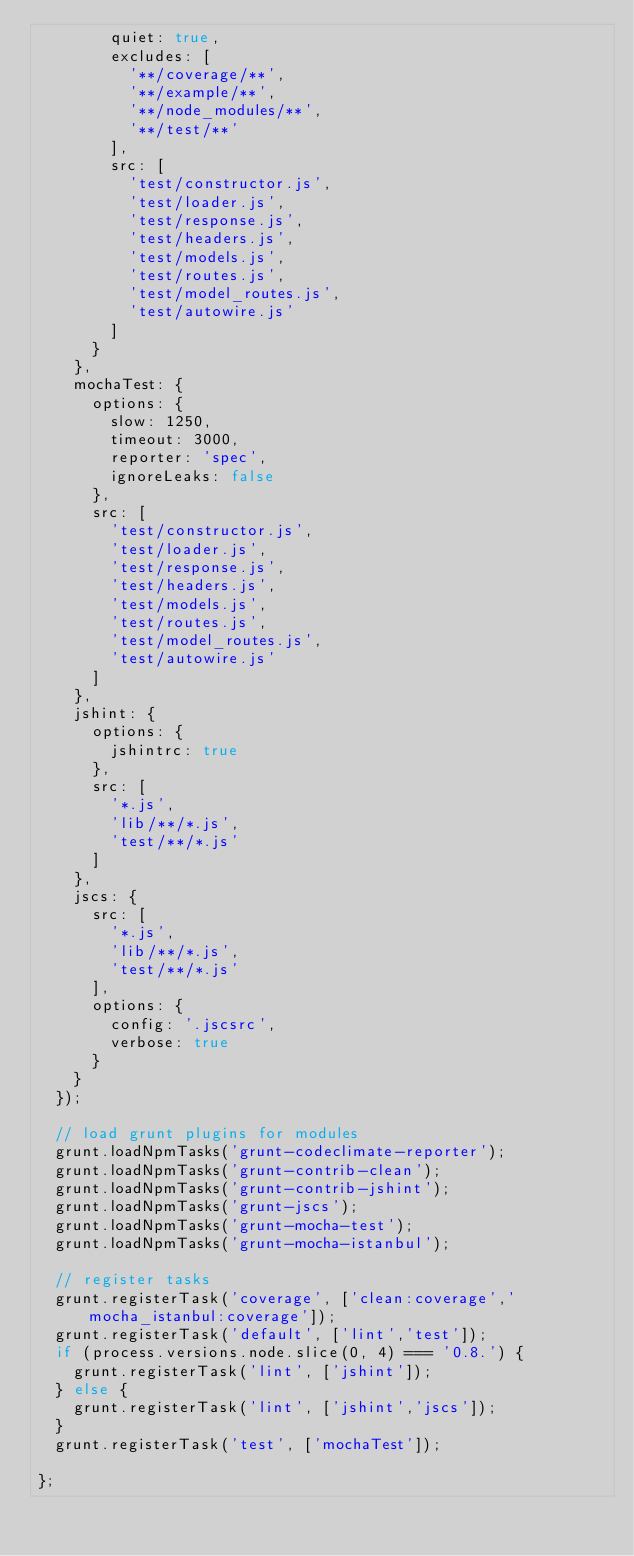<code> <loc_0><loc_0><loc_500><loc_500><_JavaScript_>        quiet: true,
        excludes: [
          '**/coverage/**',
          '**/example/**',
          '**/node_modules/**',
          '**/test/**'
        ],
        src: [
          'test/constructor.js',
          'test/loader.js',
          'test/response.js',
          'test/headers.js',
          'test/models.js',
          'test/routes.js',
          'test/model_routes.js',
          'test/autowire.js'
        ]
      }
    },
    mochaTest: {
      options: {
        slow: 1250,
        timeout: 3000,
        reporter: 'spec',
        ignoreLeaks: false
      },
      src: [
        'test/constructor.js',
        'test/loader.js',
        'test/response.js',
        'test/headers.js',
        'test/models.js',
        'test/routes.js',
        'test/model_routes.js',
        'test/autowire.js'
      ]
    },
    jshint: {
      options: {
        jshintrc: true
      },
      src: [
        '*.js',
        'lib/**/*.js',
        'test/**/*.js'
      ]
    },
    jscs: {
      src: [
        '*.js',
        'lib/**/*.js',
        'test/**/*.js'
      ],
      options: {
        config: '.jscsrc',
        verbose: true
      }
    }
  });

  // load grunt plugins for modules
  grunt.loadNpmTasks('grunt-codeclimate-reporter');
  grunt.loadNpmTasks('grunt-contrib-clean');
  grunt.loadNpmTasks('grunt-contrib-jshint');
  grunt.loadNpmTasks('grunt-jscs');
  grunt.loadNpmTasks('grunt-mocha-test');
  grunt.loadNpmTasks('grunt-mocha-istanbul');

  // register tasks
  grunt.registerTask('coverage', ['clean:coverage','mocha_istanbul:coverage']);
  grunt.registerTask('default', ['lint','test']);
  if (process.versions.node.slice(0, 4) === '0.8.') {
    grunt.registerTask('lint', ['jshint']);
  } else {
    grunt.registerTask('lint', ['jshint','jscs']);
  }
  grunt.registerTask('test', ['mochaTest']);

};
</code> 